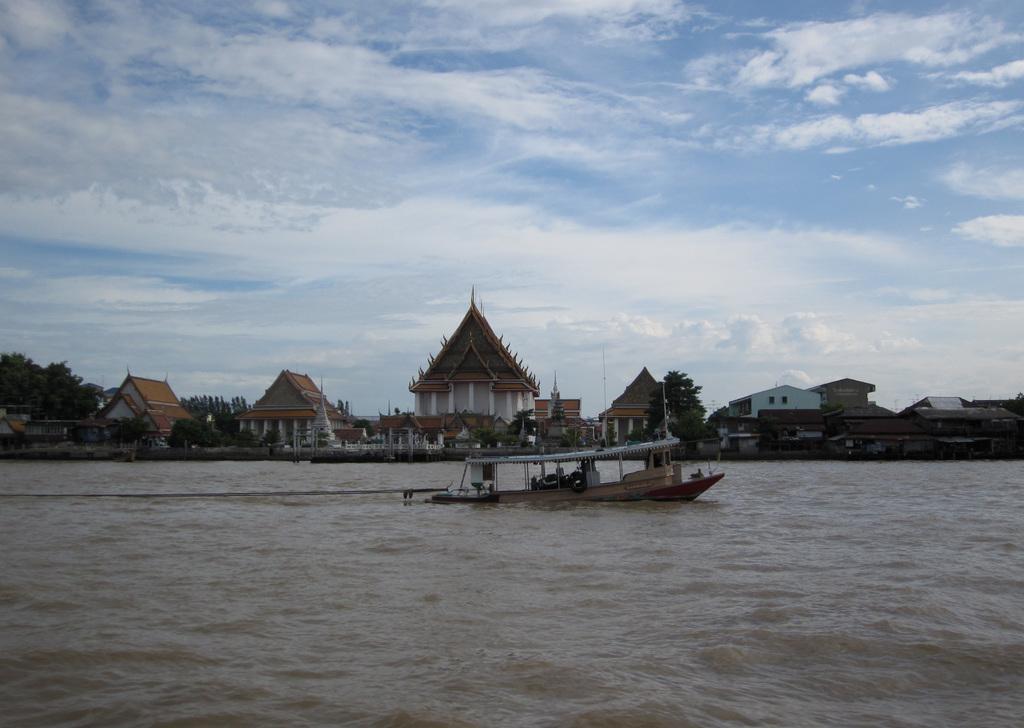Can you describe this image briefly? Here I can see a boat on the water. In the background there are many buildings and trees. At the top of the image I can see the sky and clouds. 